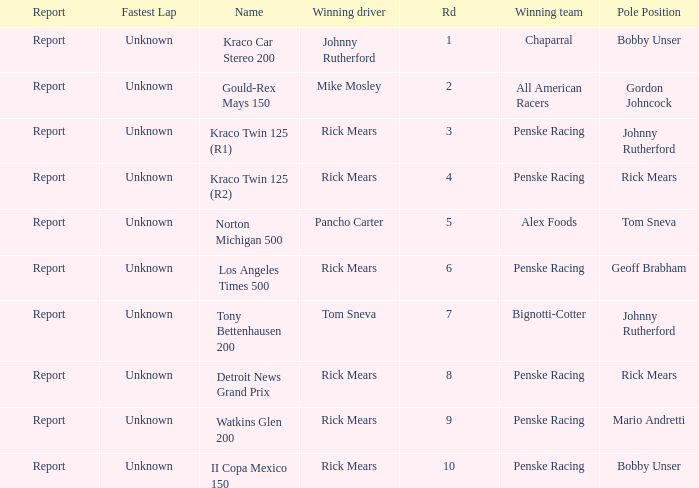The race tony bettenhausen 200 has what smallest rd? 7.0. 